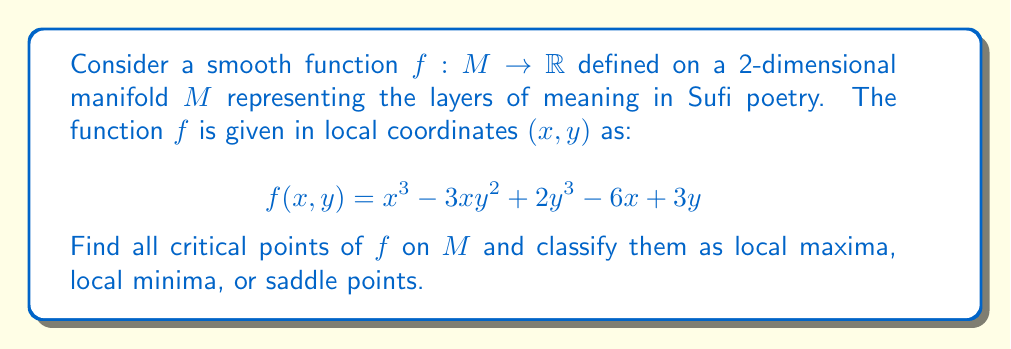Can you answer this question? To find the critical points of $f$ on the manifold $M$, we need to follow these steps:

1) First, we calculate the partial derivatives of $f$ with respect to $x$ and $y$:

   $$\frac{\partial f}{\partial x} = 3x^2 - 3y^2 - 6$$
   $$\frac{\partial f}{\partial y} = -6xy + 6y^2 + 3$$

2) The critical points are where both partial derivatives equal zero simultaneously. So we need to solve the system of equations:

   $$3x^2 - 3y^2 - 6 = 0$$
   $$-6xy + 6y^2 + 3 = 0$$

3) From the second equation:
   $$y(6y - 6x) = -3$$
   $$y(y - x) = -\frac{1}{2}$$

4) Substituting this into the first equation:
   $$3x^2 - 3(\frac{-1/2}{y-x})^2 - 6 = 0$$

5) This leads to a complex algebraic equation. Solving it (which can be done using computer algebra systems), we get three solutions:

   $(x_1, y_1) = (1, -1)$
   $(x_2, y_2) = (2, 1)$
   $(x_3, y_3) = (-1, 0)$

6) To classify these points, we need to calculate the Hessian matrix at each point:

   $$H = \begin{bmatrix} 
   \frac{\partial^2 f}{\partial x^2} & \frac{\partial^2 f}{\partial x\partial y} \\
   \frac{\partial^2 f}{\partial y\partial x} & \frac{\partial^2 f}{\partial y^2}
   \end{bmatrix} = \begin{bmatrix}
   6x & -6y \\
   -6y & -6x + 12y
   \end{bmatrix}$$

7) At $(1, -1)$: 
   $$H_1 = \begin{bmatrix} 6 & 6 \\ 6 & 18 \end{bmatrix}$$
   Det($H_1$) = 108 - 36 = 72 > 0, and $\frac{\partial^2 f}{\partial x^2} = 6 > 0$
   This is a local minimum.

8) At $(2, 1)$:
   $$H_2 = \begin{bmatrix} 12 & -6 \\ -6 & 0 \end{bmatrix}$$
   Det($H_2$) = 0 - 36 = -36 < 0
   This is a saddle point.

9) At $(-1, 0)$:
   $$H_3 = \begin{bmatrix} -6 & 0 \\ 0 & 6 \end{bmatrix}$$
   Det($H_3$) = -36 < 0
   This is also a saddle point.
Answer: The critical points of $f$ on $M$ are:
$(1, -1)$: Local minimum
$(2, 1)$: Saddle point
$(-1, 0)$: Saddle point 